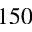<formula> <loc_0><loc_0><loc_500><loc_500>1 5 0</formula> 